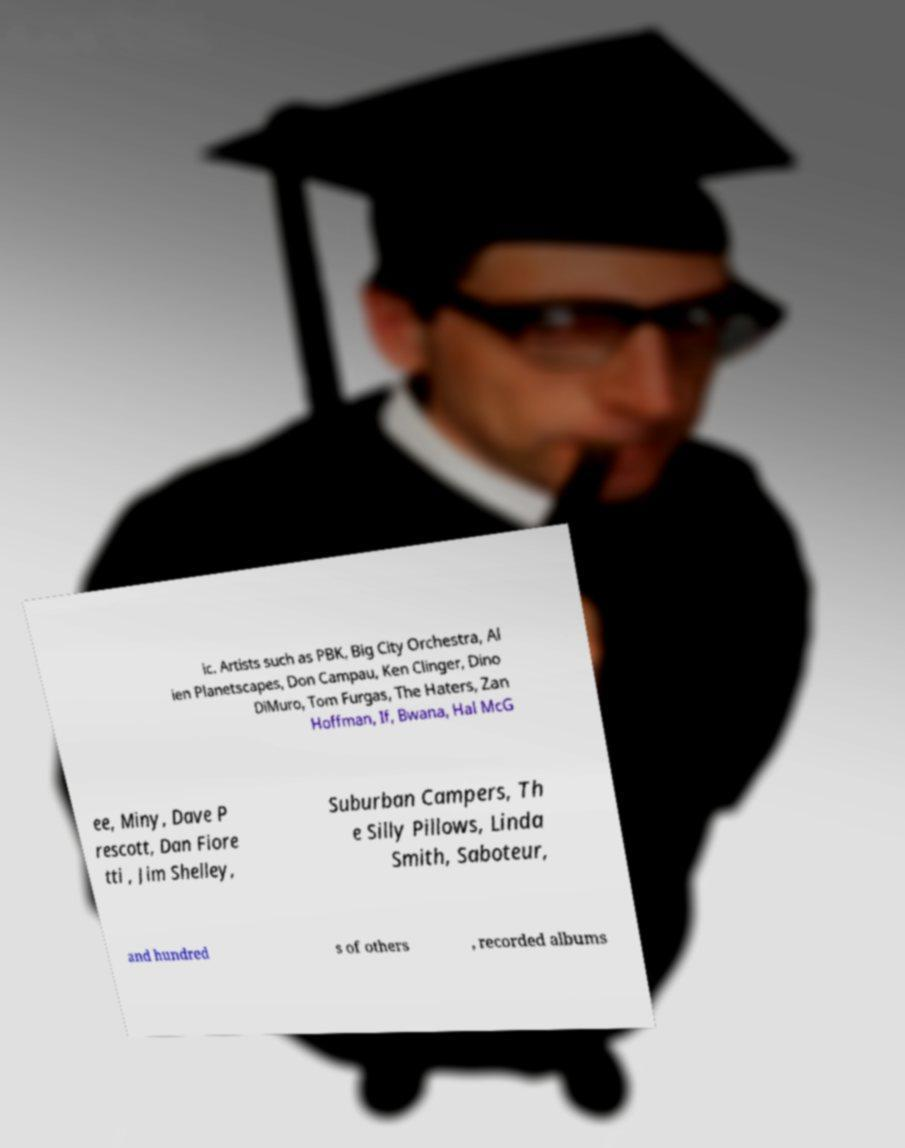There's text embedded in this image that I need extracted. Can you transcribe it verbatim? ic. Artists such as PBK, Big City Orchestra, Al ien Planetscapes, Don Campau, Ken Clinger, Dino DiMuro, Tom Furgas, The Haters, Zan Hoffman, If, Bwana, Hal McG ee, Miny, Dave P rescott, Dan Fiore tti , Jim Shelley, Suburban Campers, Th e Silly Pillows, Linda Smith, Saboteur, and hundred s of others , recorded albums 